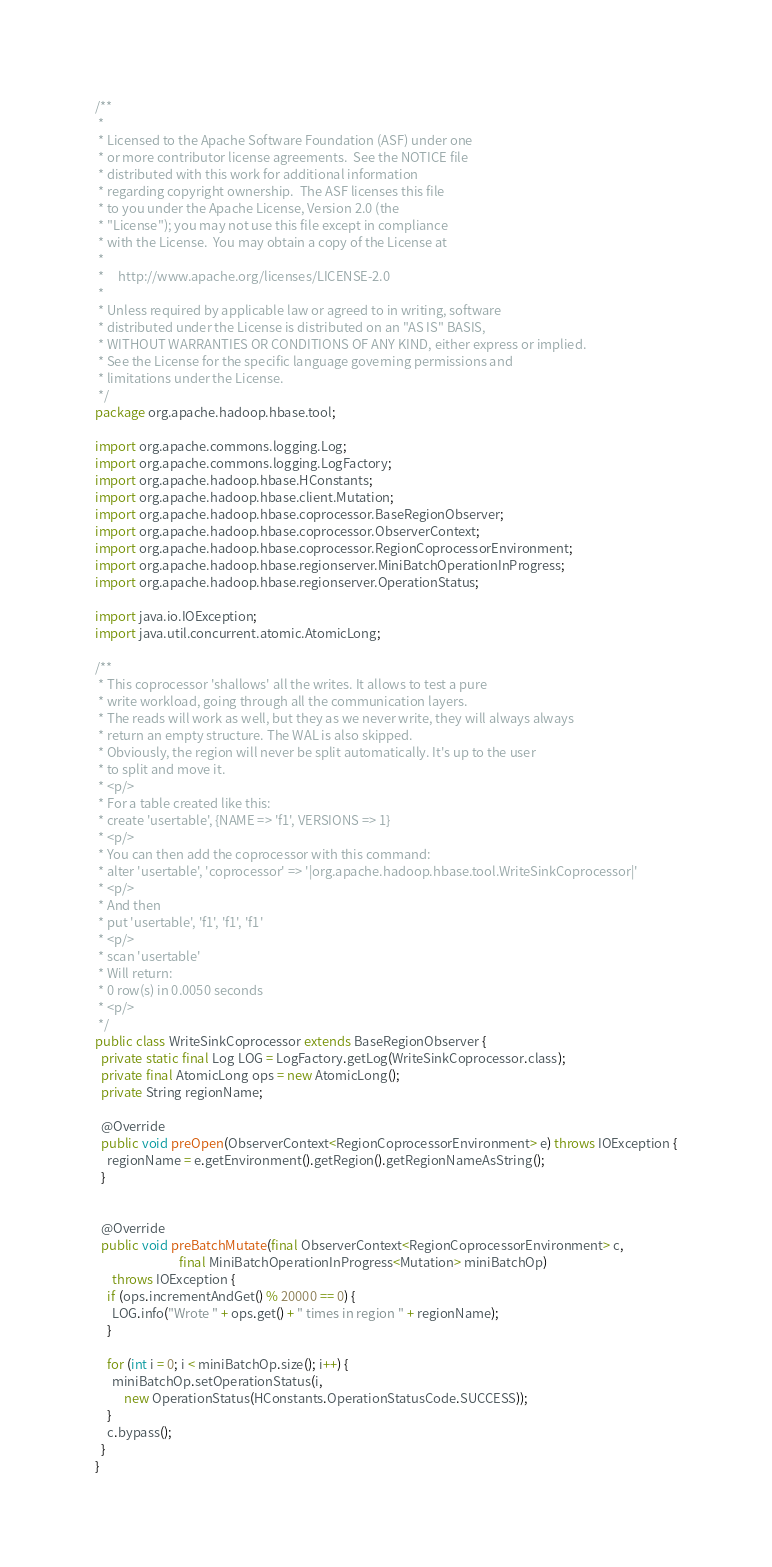<code> <loc_0><loc_0><loc_500><loc_500><_Java_>/**
 *
 * Licensed to the Apache Software Foundation (ASF) under one
 * or more contributor license agreements.  See the NOTICE file
 * distributed with this work for additional information
 * regarding copyright ownership.  The ASF licenses this file
 * to you under the Apache License, Version 2.0 (the
 * "License"); you may not use this file except in compliance
 * with the License.  You may obtain a copy of the License at
 *
 *     http://www.apache.org/licenses/LICENSE-2.0
 *
 * Unless required by applicable law or agreed to in writing, software
 * distributed under the License is distributed on an "AS IS" BASIS,
 * WITHOUT WARRANTIES OR CONDITIONS OF ANY KIND, either express or implied.
 * See the License for the specific language governing permissions and
 * limitations under the License.
 */
package org.apache.hadoop.hbase.tool;

import org.apache.commons.logging.Log;
import org.apache.commons.logging.LogFactory;
import org.apache.hadoop.hbase.HConstants;
import org.apache.hadoop.hbase.client.Mutation;
import org.apache.hadoop.hbase.coprocessor.BaseRegionObserver;
import org.apache.hadoop.hbase.coprocessor.ObserverContext;
import org.apache.hadoop.hbase.coprocessor.RegionCoprocessorEnvironment;
import org.apache.hadoop.hbase.regionserver.MiniBatchOperationInProgress;
import org.apache.hadoop.hbase.regionserver.OperationStatus;

import java.io.IOException;
import java.util.concurrent.atomic.AtomicLong;

/**
 * This coprocessor 'shallows' all the writes. It allows to test a pure
 * write workload, going through all the communication layers.
 * The reads will work as well, but they as we never write, they will always always
 * return an empty structure. The WAL is also skipped.
 * Obviously, the region will never be split automatically. It's up to the user
 * to split and move it.
 * <p/>
 * For a table created like this:
 * create 'usertable', {NAME => 'f1', VERSIONS => 1}
 * <p/>
 * You can then add the coprocessor with this command:
 * alter 'usertable', 'coprocessor' => '|org.apache.hadoop.hbase.tool.WriteSinkCoprocessor|'
 * <p/>
 * And then
 * put 'usertable', 'f1', 'f1', 'f1'
 * <p/>
 * scan 'usertable'
 * Will return:
 * 0 row(s) in 0.0050 seconds
 * <p/>
 */
public class WriteSinkCoprocessor extends BaseRegionObserver {
  private static final Log LOG = LogFactory.getLog(WriteSinkCoprocessor.class);
  private final AtomicLong ops = new AtomicLong();
  private String regionName;

  @Override
  public void preOpen(ObserverContext<RegionCoprocessorEnvironment> e) throws IOException {
    regionName = e.getEnvironment().getRegion().getRegionNameAsString();
  }


  @Override
  public void preBatchMutate(final ObserverContext<RegionCoprocessorEnvironment> c,
                             final MiniBatchOperationInProgress<Mutation> miniBatchOp)
      throws IOException {
    if (ops.incrementAndGet() % 20000 == 0) {
      LOG.info("Wrote " + ops.get() + " times in region " + regionName);
    }

    for (int i = 0; i < miniBatchOp.size(); i++) {
      miniBatchOp.setOperationStatus(i,
          new OperationStatus(HConstants.OperationStatusCode.SUCCESS));
    }
    c.bypass();
  }
}
</code> 